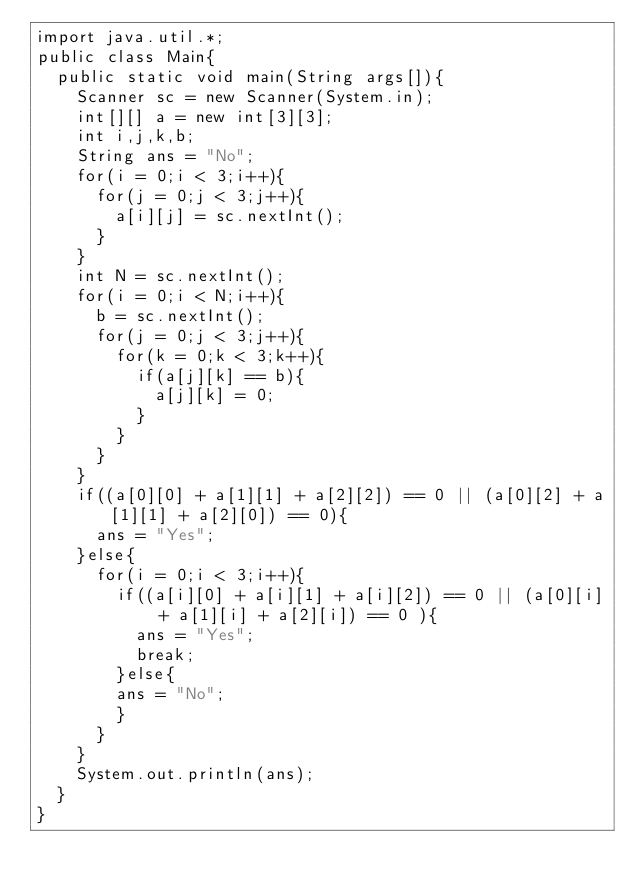Convert code to text. <code><loc_0><loc_0><loc_500><loc_500><_Java_>import java.util.*;
public class Main{
	public static void main(String args[]){
		Scanner sc = new Scanner(System.in);
		int[][] a = new int[3][3];
		int i,j,k,b;
		String ans = "No";
		for(i = 0;i < 3;i++){
			for(j = 0;j < 3;j++){
				a[i][j] = sc.nextInt();
			}
		}
		int N = sc.nextInt();
		for(i = 0;i < N;i++){
			b = sc.nextInt();
			for(j = 0;j < 3;j++){
				for(k = 0;k < 3;k++){
					if(a[j][k] == b){
						a[j][k] = 0;
					}
				}
			}
		}
		if((a[0][0] + a[1][1] + a[2][2]) == 0 || (a[0][2] + a[1][1] + a[2][0]) == 0){
			ans = "Yes";
		}else{
			for(i = 0;i < 3;i++){
				if((a[i][0] + a[i][1] + a[i][2]) == 0 || (a[0][i] + a[1][i] + a[2][i]) == 0 ){
					ans = "Yes";
					break;
				}else{
				ans = "No";
				}
			}
		}
		System.out.println(ans);
	}
}</code> 